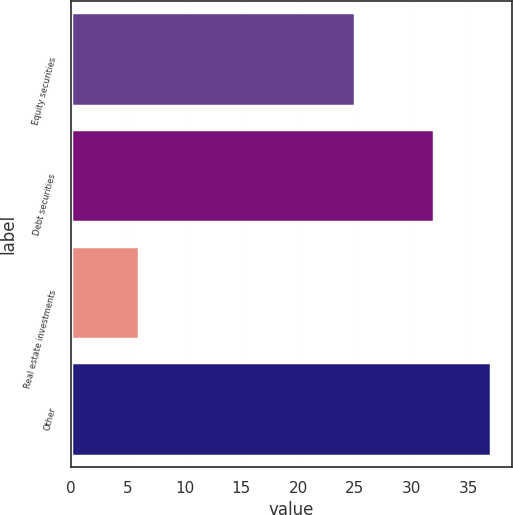Convert chart. <chart><loc_0><loc_0><loc_500><loc_500><bar_chart><fcel>Equity securities<fcel>Debt securities<fcel>Real estate investments<fcel>Other<nl><fcel>25<fcel>32<fcel>6<fcel>37<nl></chart> 